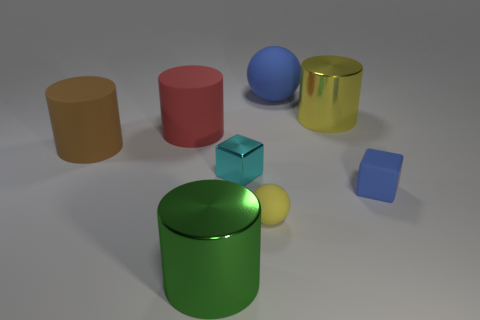How many things are things that are in front of the large brown object or matte things that are on the left side of the green shiny cylinder?
Ensure brevity in your answer.  6. What number of other things are there of the same color as the big ball?
Give a very brief answer. 1. Are there more large blue rubber things that are right of the red matte object than cyan shiny blocks on the right side of the blue cube?
Ensure brevity in your answer.  Yes. What number of balls are either big green metal objects or cyan metallic things?
Provide a succinct answer. 0. What number of things are tiny yellow matte things in front of the tiny cyan metallic object or metal things?
Provide a succinct answer. 4. The rubber object right of the matte sphere behind the small yellow object right of the small cyan metallic object is what shape?
Make the answer very short. Cube. How many large brown objects are the same shape as the yellow matte thing?
Offer a very short reply. 0. There is a thing that is the same color as the tiny matte sphere; what is it made of?
Your response must be concise. Metal. Are the large green object and the yellow sphere made of the same material?
Your answer should be very brief. No. What number of tiny yellow objects are behind the big thing that is behind the shiny cylinder that is behind the tiny yellow sphere?
Keep it short and to the point. 0. 